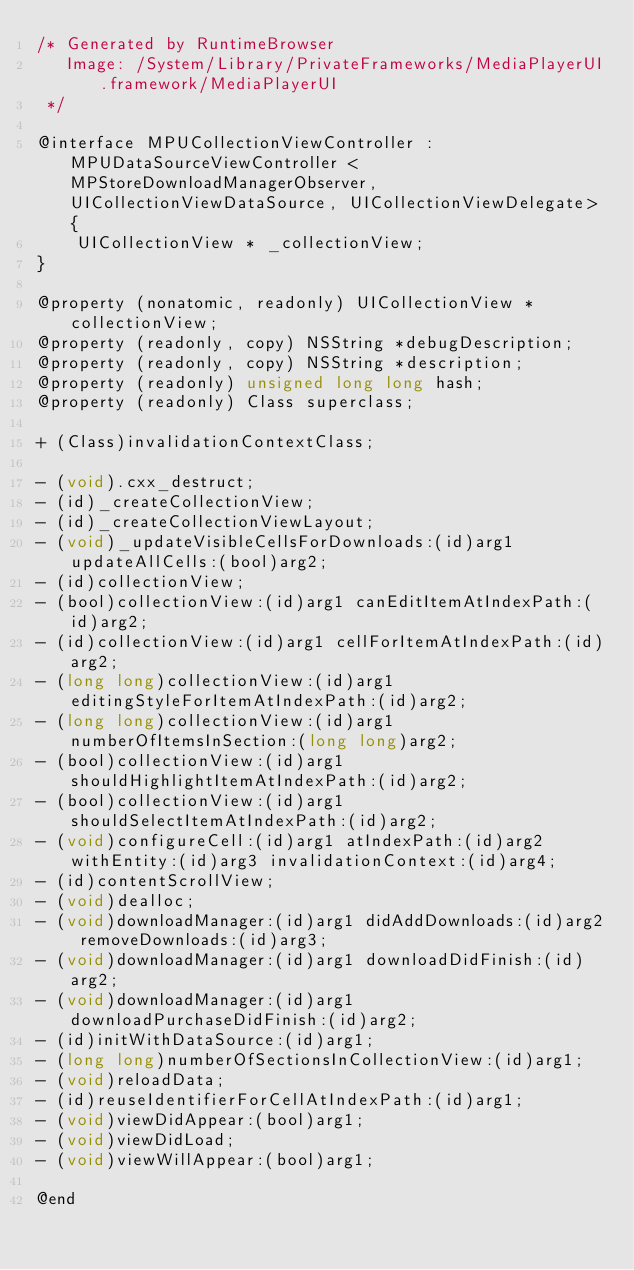Convert code to text. <code><loc_0><loc_0><loc_500><loc_500><_C_>/* Generated by RuntimeBrowser
   Image: /System/Library/PrivateFrameworks/MediaPlayerUI.framework/MediaPlayerUI
 */

@interface MPUCollectionViewController : MPUDataSourceViewController <MPStoreDownloadManagerObserver, UICollectionViewDataSource, UICollectionViewDelegate> {
    UICollectionView * _collectionView;
}

@property (nonatomic, readonly) UICollectionView *collectionView;
@property (readonly, copy) NSString *debugDescription;
@property (readonly, copy) NSString *description;
@property (readonly) unsigned long long hash;
@property (readonly) Class superclass;

+ (Class)invalidationContextClass;

- (void).cxx_destruct;
- (id)_createCollectionView;
- (id)_createCollectionViewLayout;
- (void)_updateVisibleCellsForDownloads:(id)arg1 updateAllCells:(bool)arg2;
- (id)collectionView;
- (bool)collectionView:(id)arg1 canEditItemAtIndexPath:(id)arg2;
- (id)collectionView:(id)arg1 cellForItemAtIndexPath:(id)arg2;
- (long long)collectionView:(id)arg1 editingStyleForItemAtIndexPath:(id)arg2;
- (long long)collectionView:(id)arg1 numberOfItemsInSection:(long long)arg2;
- (bool)collectionView:(id)arg1 shouldHighlightItemAtIndexPath:(id)arg2;
- (bool)collectionView:(id)arg1 shouldSelectItemAtIndexPath:(id)arg2;
- (void)configureCell:(id)arg1 atIndexPath:(id)arg2 withEntity:(id)arg3 invalidationContext:(id)arg4;
- (id)contentScrollView;
- (void)dealloc;
- (void)downloadManager:(id)arg1 didAddDownloads:(id)arg2 removeDownloads:(id)arg3;
- (void)downloadManager:(id)arg1 downloadDidFinish:(id)arg2;
- (void)downloadManager:(id)arg1 downloadPurchaseDidFinish:(id)arg2;
- (id)initWithDataSource:(id)arg1;
- (long long)numberOfSectionsInCollectionView:(id)arg1;
- (void)reloadData;
- (id)reuseIdentifierForCellAtIndexPath:(id)arg1;
- (void)viewDidAppear:(bool)arg1;
- (void)viewDidLoad;
- (void)viewWillAppear:(bool)arg1;

@end
</code> 